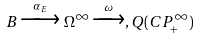<formula> <loc_0><loc_0><loc_500><loc_500>B \xrightarrow { \, \alpha _ { E } \, } \Omega ^ { \infty } \xrightarrow { \, \omega \, } , Q ( C P _ { + } ^ { \infty } )</formula> 